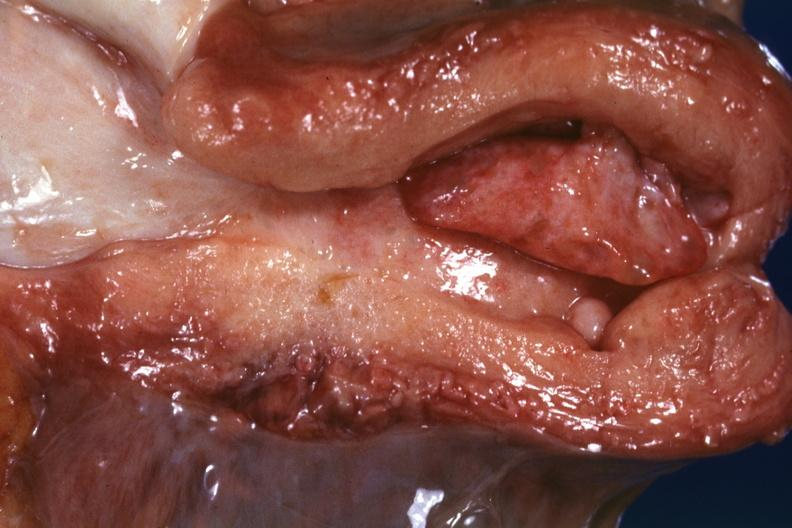where does this part belong to?
Answer the question using a single word or phrase. Female reproductive system 